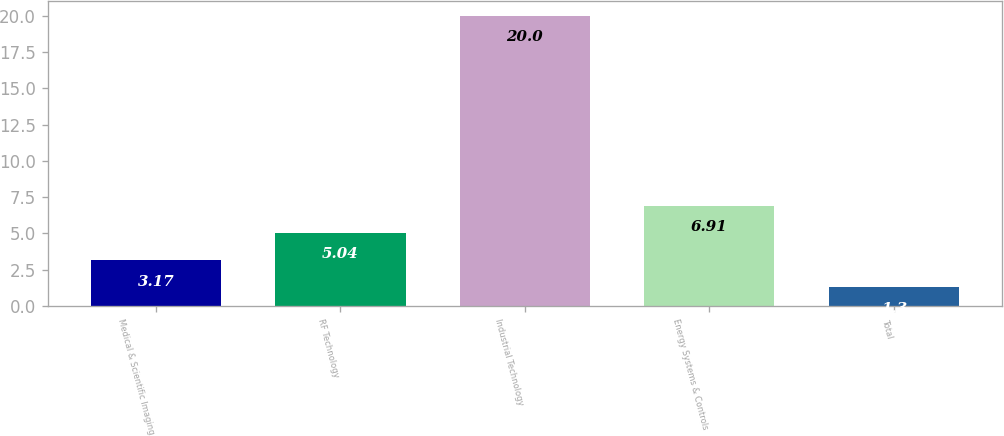Convert chart. <chart><loc_0><loc_0><loc_500><loc_500><bar_chart><fcel>Medical & Scientific Imaging<fcel>RF Technology<fcel>Industrial Technology<fcel>Energy Systems & Controls<fcel>Total<nl><fcel>3.17<fcel>5.04<fcel>20<fcel>6.91<fcel>1.3<nl></chart> 